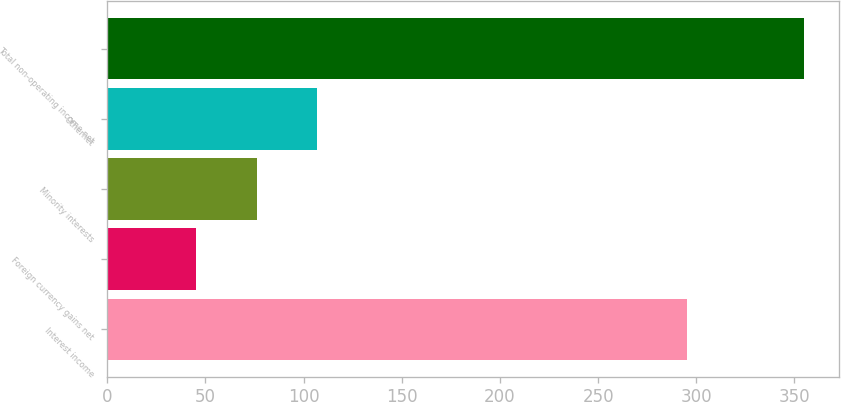Convert chart. <chart><loc_0><loc_0><loc_500><loc_500><bar_chart><fcel>Interest income<fcel>Foreign currency gains net<fcel>Minority interests<fcel>Othernet<fcel>Total non-operating income net<nl><fcel>295<fcel>45<fcel>76<fcel>107<fcel>355<nl></chart> 